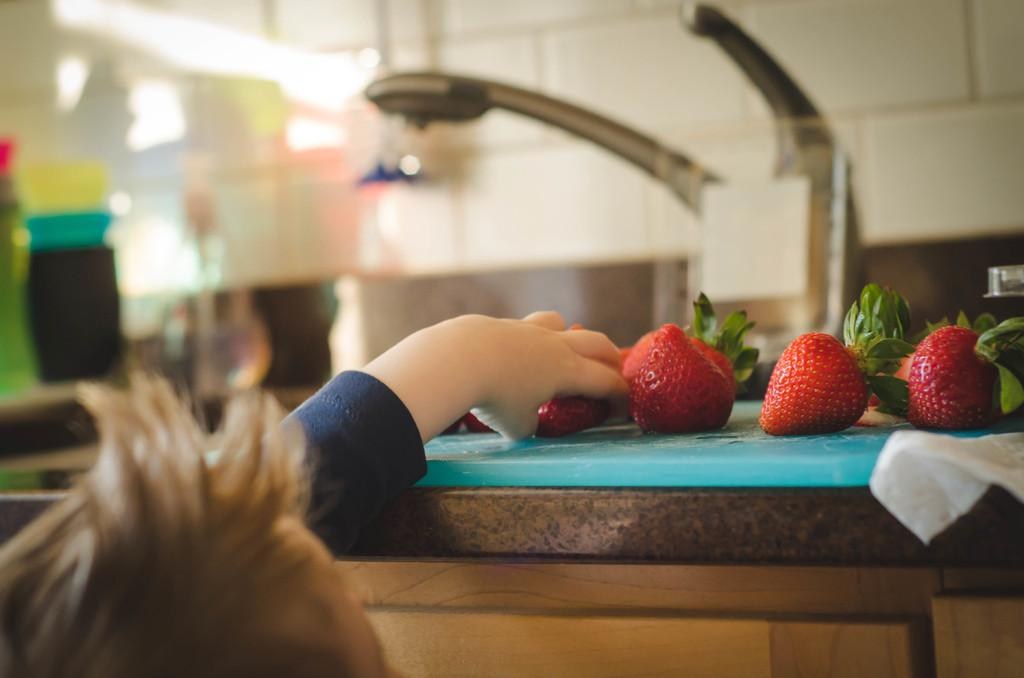What type of food can be seen in the image? There are fruits in the image. Can you describe the person in the image? There is a person in the image. What else is present in the image besides the fruits and person? There are objects in the image. How would you describe the background at the top of the image? The background at the top of the image is blurred. What type of trick is the person performing with the branch and orange in the image? There is no branch or orange present in the image, and therefore no trick can be observed. 